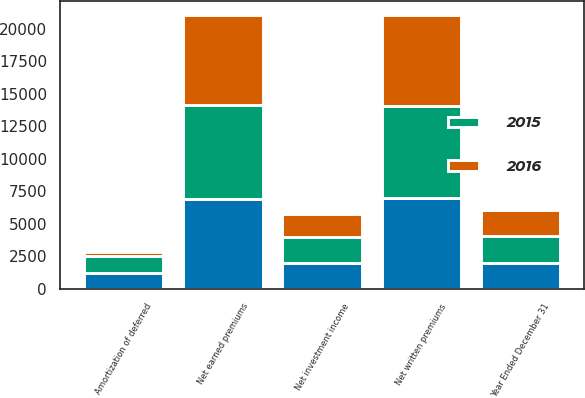Convert chart to OTSL. <chart><loc_0><loc_0><loc_500><loc_500><stacked_bar_chart><ecel><fcel>Year Ended December 31<fcel>Net written premiums<fcel>Net earned premiums<fcel>Net investment income<fcel>Amortization of deferred<nl><fcel>nan<fcel>2016<fcel>6988<fcel>6924<fcel>1952<fcel>1235<nl><fcel>2016<fcel>2015<fcel>6962<fcel>6921<fcel>1807<fcel>255<nl><fcel>2015<fcel>2014<fcel>7088<fcel>7212<fcel>2031<fcel>1317<nl></chart> 